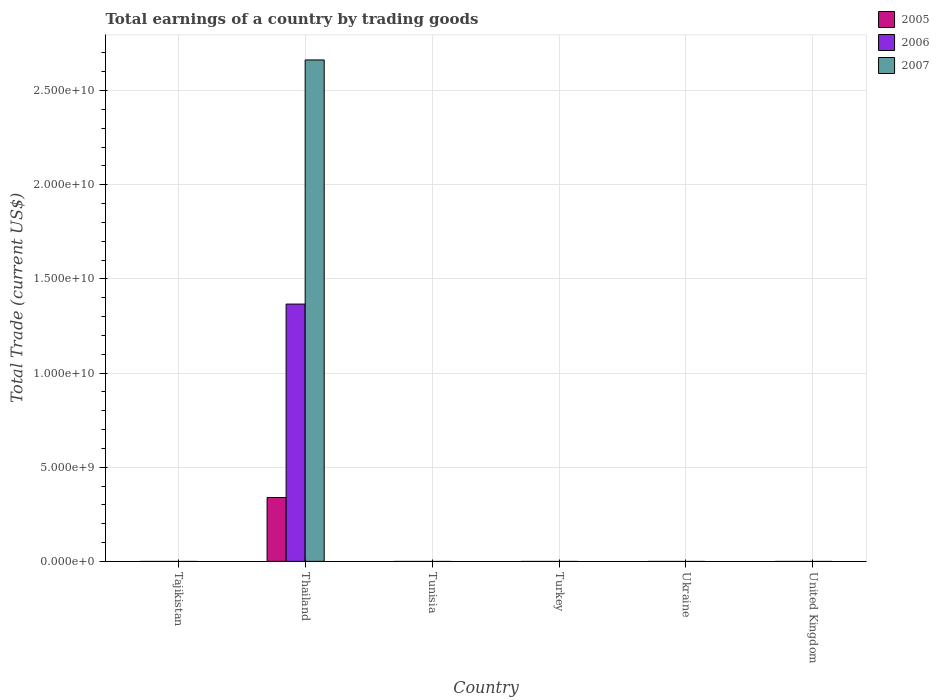How many different coloured bars are there?
Offer a terse response. 3. How many bars are there on the 2nd tick from the left?
Offer a very short reply. 3. How many bars are there on the 5th tick from the right?
Offer a very short reply. 3. What is the label of the 3rd group of bars from the left?
Offer a very short reply. Tunisia. In how many cases, is the number of bars for a given country not equal to the number of legend labels?
Keep it short and to the point. 5. What is the total earnings in 2005 in Tunisia?
Provide a short and direct response. 0. Across all countries, what is the maximum total earnings in 2007?
Ensure brevity in your answer.  2.66e+1. Across all countries, what is the minimum total earnings in 2007?
Your answer should be compact. 0. In which country was the total earnings in 2005 maximum?
Keep it short and to the point. Thailand. What is the total total earnings in 2007 in the graph?
Offer a very short reply. 2.66e+1. What is the difference between the total earnings in 2007 in Thailand and the total earnings in 2006 in Turkey?
Make the answer very short. 2.66e+1. What is the average total earnings in 2006 per country?
Provide a short and direct response. 2.28e+09. In how many countries, is the total earnings in 2007 greater than 25000000000 US$?
Make the answer very short. 1. What is the difference between the highest and the lowest total earnings in 2005?
Offer a very short reply. 3.39e+09. In how many countries, is the total earnings in 2007 greater than the average total earnings in 2007 taken over all countries?
Provide a succinct answer. 1. Is it the case that in every country, the sum of the total earnings in 2005 and total earnings in 2007 is greater than the total earnings in 2006?
Provide a succinct answer. No. How many bars are there?
Provide a succinct answer. 3. Are all the bars in the graph horizontal?
Ensure brevity in your answer.  No. What is the difference between two consecutive major ticks on the Y-axis?
Provide a short and direct response. 5.00e+09. Are the values on the major ticks of Y-axis written in scientific E-notation?
Offer a very short reply. Yes. Where does the legend appear in the graph?
Keep it short and to the point. Top right. What is the title of the graph?
Keep it short and to the point. Total earnings of a country by trading goods. What is the label or title of the Y-axis?
Keep it short and to the point. Total Trade (current US$). What is the Total Trade (current US$) in 2005 in Tajikistan?
Keep it short and to the point. 0. What is the Total Trade (current US$) of 2006 in Tajikistan?
Make the answer very short. 0. What is the Total Trade (current US$) in 2005 in Thailand?
Your answer should be very brief. 3.39e+09. What is the Total Trade (current US$) of 2006 in Thailand?
Offer a very short reply. 1.37e+1. What is the Total Trade (current US$) in 2007 in Thailand?
Offer a terse response. 2.66e+1. What is the Total Trade (current US$) of 2005 in Tunisia?
Offer a terse response. 0. What is the Total Trade (current US$) of 2007 in Tunisia?
Keep it short and to the point. 0. What is the Total Trade (current US$) of 2006 in Turkey?
Your answer should be very brief. 0. What is the Total Trade (current US$) of 2007 in Turkey?
Keep it short and to the point. 0. What is the Total Trade (current US$) in 2005 in Ukraine?
Offer a very short reply. 0. What is the Total Trade (current US$) in 2006 in Ukraine?
Your answer should be compact. 0. What is the Total Trade (current US$) in 2005 in United Kingdom?
Offer a very short reply. 0. Across all countries, what is the maximum Total Trade (current US$) in 2005?
Give a very brief answer. 3.39e+09. Across all countries, what is the maximum Total Trade (current US$) of 2006?
Keep it short and to the point. 1.37e+1. Across all countries, what is the maximum Total Trade (current US$) of 2007?
Offer a terse response. 2.66e+1. Across all countries, what is the minimum Total Trade (current US$) of 2005?
Offer a terse response. 0. What is the total Total Trade (current US$) of 2005 in the graph?
Offer a very short reply. 3.39e+09. What is the total Total Trade (current US$) of 2006 in the graph?
Keep it short and to the point. 1.37e+1. What is the total Total Trade (current US$) in 2007 in the graph?
Offer a terse response. 2.66e+1. What is the average Total Trade (current US$) of 2005 per country?
Give a very brief answer. 5.65e+08. What is the average Total Trade (current US$) of 2006 per country?
Provide a short and direct response. 2.28e+09. What is the average Total Trade (current US$) in 2007 per country?
Give a very brief answer. 4.44e+09. What is the difference between the Total Trade (current US$) in 2005 and Total Trade (current US$) in 2006 in Thailand?
Give a very brief answer. -1.03e+1. What is the difference between the Total Trade (current US$) of 2005 and Total Trade (current US$) of 2007 in Thailand?
Keep it short and to the point. -2.32e+1. What is the difference between the Total Trade (current US$) in 2006 and Total Trade (current US$) in 2007 in Thailand?
Offer a terse response. -1.30e+1. What is the difference between the highest and the lowest Total Trade (current US$) of 2005?
Your answer should be compact. 3.39e+09. What is the difference between the highest and the lowest Total Trade (current US$) in 2006?
Offer a terse response. 1.37e+1. What is the difference between the highest and the lowest Total Trade (current US$) of 2007?
Provide a succinct answer. 2.66e+1. 